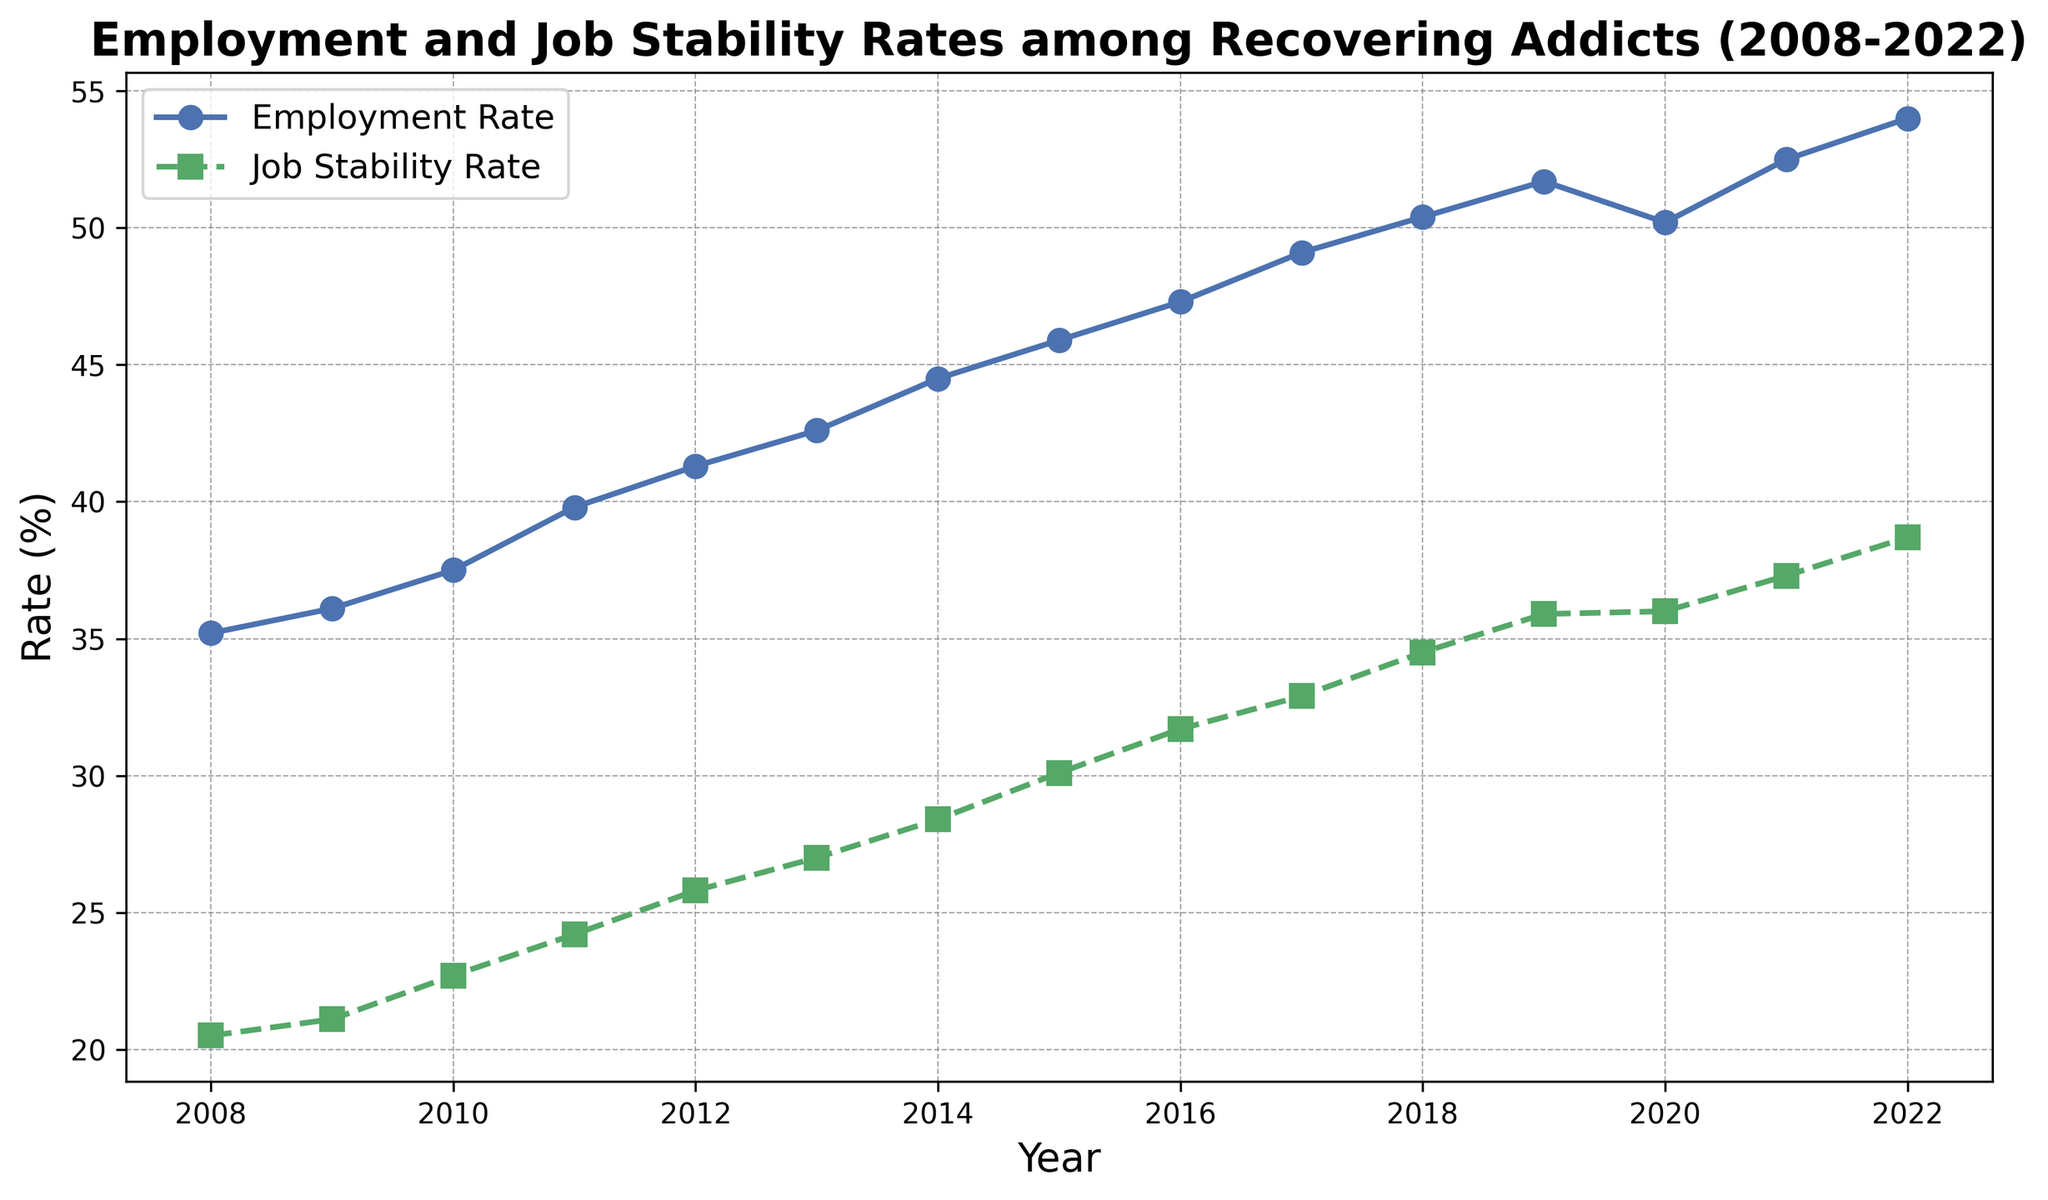How did the employment rate change from 2008 to 2022? To find the change, subtract the employment rate in 2008 from the employment rate in 2022. The employment rate in 2022 is 54.0%, and in 2008 it was 35.2%. The change is 54.0 - 35.2 = 18.8.
Answer: 18.8% In which year did the job stability rate first exceed 30%? The job stability rate first exceeds 30% in 2015 with a rate of 30.1%. This is found by looking at the job stability rate column year by year until it goes above 30%.
Answer: 2015 What is the average employment rate over the 15 years? To find the average employment rate, sum the employment rates for all the years and then divide by the number of years. Sum = 35.2 + 36.1 + 37.5 + 39.8 + 41.3 + 42.6 + 44.5 + 45.9 + 47.3 + 49.1 + 50.4 + 51.7 + 50.2 + 52.5 + 54.0 = 678.1. Average = 678.1 / 15 = 45.2.
Answer: 45.2% Which year shows a decline in the employment rate compared to the previous year? Compare each year's employment rate with the previous year's rate. The employment rate declines from 51.7% in 2019 to 50.2% in 2020.
Answer: 2020 What is the maximum difference between employment rate and job stability rate in any year? Calculate the difference for each year and find the maximum. Differences: 2008 (14.7), 2009 (15.0), 2010 (14.8), 2011 (15.6), 2012 (15.5), 2013 (15.6), 2014 (16.1), 2015 (15.8), 2016 (15.6), 2017 (16.2), 2018 (15.9), 2019 (15.8), 2020 (14.2), 2021 (15.2), 2022 (15.3). The maximum difference is 16.2 in 2017.
Answer: 16.2% Which rate had a steeper increase over the 15 years, employment or job stability? Calculate the increase for both. Employment rate increase = 54.0 - 35.2 = 18.8. Job stability rate increase = 38.7 - 20.5 = 18.2. Since 18.8 > 18.2, the employment rate increased more steeply.
Answer: Employment rate Was there any year where both employment rate and job stability rate increased by the same amount? Compare the year-over-year changes for both rates. In 2019-2020, Employment rate change = 50.2 - 51.7 = -1.5, Job stability rate change = 36.0 - 35.9 = 0.1. No year has the same amount of increase.
Answer: No 